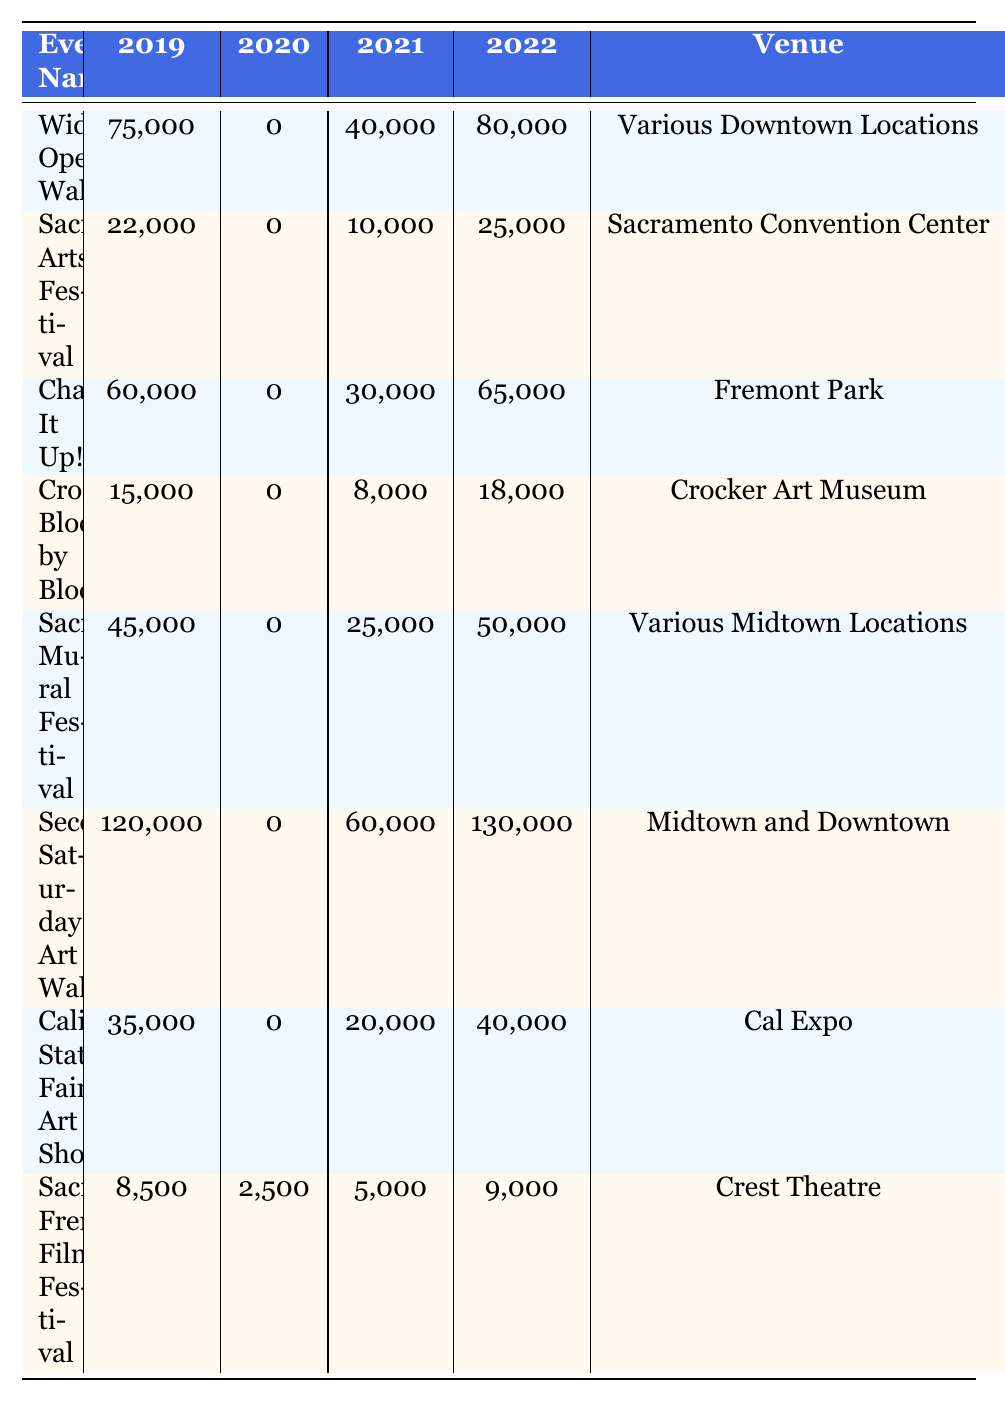What was the attendance for the "Second Saturday Art Walk" in 2022? In the "Second Saturday Art Walk" row under the "2022 Attendance" column, the attendance figure is listed as 130,000.
Answer: 130,000 What is the venue for the "Sacramento Mural Festival"? In the "Sacramento Mural Festival" row, the venue is noted as "Various Midtown Locations".
Answer: Various Midtown Locations Which event had the highest attendance in 2019? By reviewing the "2019 Attendance" column, "Second Saturday Art Walk" shows the highest figure of 120,000 attendees.
Answer: Second Saturday Art Walk What was the total attendance for the "Crocker Block by Block" event from 2019 to 2022? Adding the attendance figures: 15,000 (2019) + 0 (2020) + 8,000 (2021) + 18,000 (2022) gives a total of 41,000.
Answer: 41,000 Did "Sacramento Arts Festival" have an attendance figure higher than 20,000 in any year? Checking the attendance figures for all years shows the maximum was 25,000 in 2022, which is above 20,000.
Answer: Yes What is the difference in attendance for "Wide Open Walls" between 2019 and 2022? The attendance in 2019 was 75,000 and in 2022 it was 80,000. Calculating the difference: 80,000 - 75,000 = 5,000.
Answer: 5,000 What was the average attendance across all events in 2021? Summing all attendees for 2021: 40,000 + 10,000 + 30,000 + 8,000 + 25,000 + 60,000 + 20,000 + 5,000 = 198,000. Dividing by 8 events gives an average of 24,750.
Answer: 24,750 Which event had the least attendance in the year 2022? Looking at the "2022 Attendance" column, "Sacramento French Film Festival" had the lowest attendance at 9,000.
Answer: Sacramento French Film Festival How many events took place in June? Counting the occurrences of June in the "Month" column, we see "Sacramento Mural Festival" and "Sacramento French Film Festival", totaling 2 events.
Answer: 2 Was there an event that did not occur in 2020? Observing the attendance in 2020 for all events, we note that all events except for the "Sacramento French Film Festival" had an attendance of 0, indicating no occurrences.
Answer: Yes 